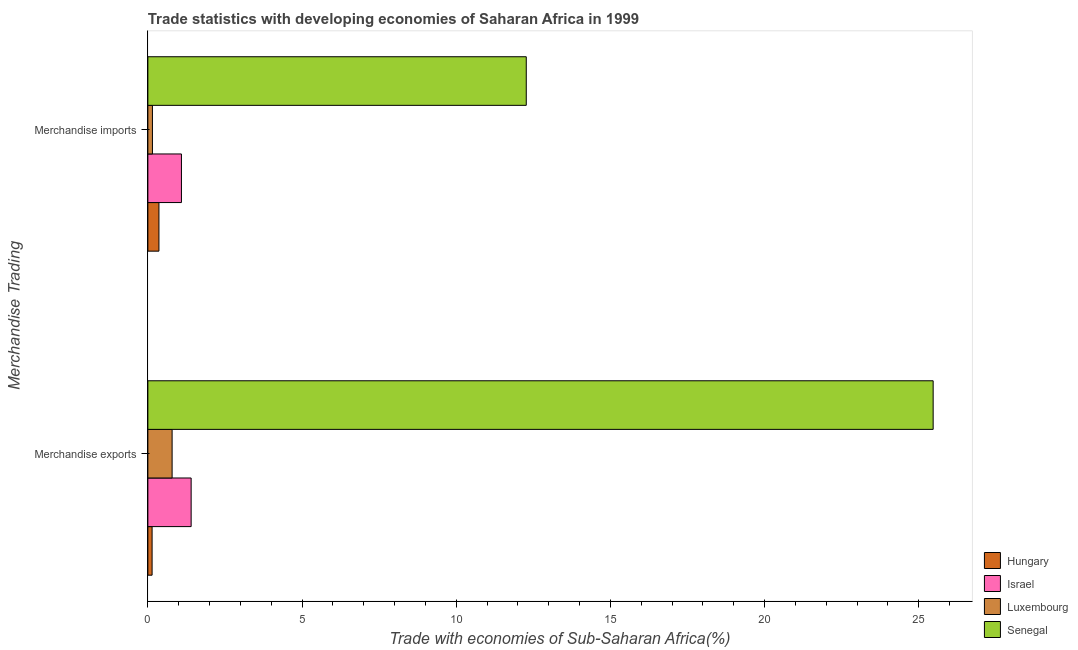How many different coloured bars are there?
Your response must be concise. 4. How many groups of bars are there?
Make the answer very short. 2. Are the number of bars per tick equal to the number of legend labels?
Give a very brief answer. Yes. Are the number of bars on each tick of the Y-axis equal?
Make the answer very short. Yes. How many bars are there on the 1st tick from the bottom?
Give a very brief answer. 4. What is the merchandise exports in Israel?
Give a very brief answer. 1.4. Across all countries, what is the maximum merchandise exports?
Provide a short and direct response. 25.47. Across all countries, what is the minimum merchandise imports?
Keep it short and to the point. 0.15. In which country was the merchandise imports maximum?
Make the answer very short. Senegal. In which country was the merchandise imports minimum?
Offer a terse response. Luxembourg. What is the total merchandise exports in the graph?
Offer a terse response. 27.8. What is the difference between the merchandise imports in Hungary and that in Israel?
Keep it short and to the point. -0.73. What is the difference between the merchandise imports in Israel and the merchandise exports in Luxembourg?
Provide a succinct answer. 0.3. What is the average merchandise exports per country?
Provide a succinct answer. 6.95. What is the difference between the merchandise imports and merchandise exports in Luxembourg?
Make the answer very short. -0.64. What is the ratio of the merchandise imports in Luxembourg to that in Israel?
Your response must be concise. 0.14. Is the merchandise imports in Senegal less than that in Hungary?
Give a very brief answer. No. In how many countries, is the merchandise exports greater than the average merchandise exports taken over all countries?
Offer a very short reply. 1. What does the 2nd bar from the top in Merchandise exports represents?
Provide a short and direct response. Luxembourg. Are all the bars in the graph horizontal?
Your answer should be very brief. Yes. Are the values on the major ticks of X-axis written in scientific E-notation?
Keep it short and to the point. No. Where does the legend appear in the graph?
Offer a terse response. Bottom right. How many legend labels are there?
Offer a terse response. 4. What is the title of the graph?
Ensure brevity in your answer.  Trade statistics with developing economies of Saharan Africa in 1999. Does "Netherlands" appear as one of the legend labels in the graph?
Your answer should be compact. No. What is the label or title of the X-axis?
Offer a terse response. Trade with economies of Sub-Saharan Africa(%). What is the label or title of the Y-axis?
Give a very brief answer. Merchandise Trading. What is the Trade with economies of Sub-Saharan Africa(%) of Hungary in Merchandise exports?
Give a very brief answer. 0.14. What is the Trade with economies of Sub-Saharan Africa(%) of Israel in Merchandise exports?
Keep it short and to the point. 1.4. What is the Trade with economies of Sub-Saharan Africa(%) in Luxembourg in Merchandise exports?
Your answer should be very brief. 0.79. What is the Trade with economies of Sub-Saharan Africa(%) in Senegal in Merchandise exports?
Your response must be concise. 25.47. What is the Trade with economies of Sub-Saharan Africa(%) in Hungary in Merchandise imports?
Offer a very short reply. 0.36. What is the Trade with economies of Sub-Saharan Africa(%) of Israel in Merchandise imports?
Give a very brief answer. 1.09. What is the Trade with economies of Sub-Saharan Africa(%) of Luxembourg in Merchandise imports?
Ensure brevity in your answer.  0.15. What is the Trade with economies of Sub-Saharan Africa(%) in Senegal in Merchandise imports?
Give a very brief answer. 12.27. Across all Merchandise Trading, what is the maximum Trade with economies of Sub-Saharan Africa(%) of Hungary?
Your response must be concise. 0.36. Across all Merchandise Trading, what is the maximum Trade with economies of Sub-Saharan Africa(%) of Israel?
Offer a terse response. 1.4. Across all Merchandise Trading, what is the maximum Trade with economies of Sub-Saharan Africa(%) in Luxembourg?
Keep it short and to the point. 0.79. Across all Merchandise Trading, what is the maximum Trade with economies of Sub-Saharan Africa(%) of Senegal?
Your answer should be very brief. 25.47. Across all Merchandise Trading, what is the minimum Trade with economies of Sub-Saharan Africa(%) in Hungary?
Your response must be concise. 0.14. Across all Merchandise Trading, what is the minimum Trade with economies of Sub-Saharan Africa(%) in Israel?
Offer a very short reply. 1.09. Across all Merchandise Trading, what is the minimum Trade with economies of Sub-Saharan Africa(%) in Luxembourg?
Provide a succinct answer. 0.15. Across all Merchandise Trading, what is the minimum Trade with economies of Sub-Saharan Africa(%) in Senegal?
Your response must be concise. 12.27. What is the total Trade with economies of Sub-Saharan Africa(%) of Hungary in the graph?
Your answer should be compact. 0.5. What is the total Trade with economies of Sub-Saharan Africa(%) of Israel in the graph?
Provide a short and direct response. 2.49. What is the total Trade with economies of Sub-Saharan Africa(%) of Luxembourg in the graph?
Make the answer very short. 0.93. What is the total Trade with economies of Sub-Saharan Africa(%) of Senegal in the graph?
Your answer should be very brief. 37.74. What is the difference between the Trade with economies of Sub-Saharan Africa(%) of Hungary in Merchandise exports and that in Merchandise imports?
Your answer should be compact. -0.22. What is the difference between the Trade with economies of Sub-Saharan Africa(%) in Israel in Merchandise exports and that in Merchandise imports?
Make the answer very short. 0.31. What is the difference between the Trade with economies of Sub-Saharan Africa(%) in Luxembourg in Merchandise exports and that in Merchandise imports?
Your answer should be compact. 0.64. What is the difference between the Trade with economies of Sub-Saharan Africa(%) of Senegal in Merchandise exports and that in Merchandise imports?
Offer a very short reply. 13.2. What is the difference between the Trade with economies of Sub-Saharan Africa(%) of Hungary in Merchandise exports and the Trade with economies of Sub-Saharan Africa(%) of Israel in Merchandise imports?
Keep it short and to the point. -0.95. What is the difference between the Trade with economies of Sub-Saharan Africa(%) of Hungary in Merchandise exports and the Trade with economies of Sub-Saharan Africa(%) of Luxembourg in Merchandise imports?
Ensure brevity in your answer.  -0.01. What is the difference between the Trade with economies of Sub-Saharan Africa(%) of Hungary in Merchandise exports and the Trade with economies of Sub-Saharan Africa(%) of Senegal in Merchandise imports?
Offer a terse response. -12.14. What is the difference between the Trade with economies of Sub-Saharan Africa(%) of Israel in Merchandise exports and the Trade with economies of Sub-Saharan Africa(%) of Luxembourg in Merchandise imports?
Keep it short and to the point. 1.26. What is the difference between the Trade with economies of Sub-Saharan Africa(%) of Israel in Merchandise exports and the Trade with economies of Sub-Saharan Africa(%) of Senegal in Merchandise imports?
Your answer should be very brief. -10.87. What is the difference between the Trade with economies of Sub-Saharan Africa(%) of Luxembourg in Merchandise exports and the Trade with economies of Sub-Saharan Africa(%) of Senegal in Merchandise imports?
Give a very brief answer. -11.49. What is the average Trade with economies of Sub-Saharan Africa(%) in Hungary per Merchandise Trading?
Offer a very short reply. 0.25. What is the average Trade with economies of Sub-Saharan Africa(%) in Israel per Merchandise Trading?
Your answer should be very brief. 1.25. What is the average Trade with economies of Sub-Saharan Africa(%) of Luxembourg per Merchandise Trading?
Your answer should be very brief. 0.47. What is the average Trade with economies of Sub-Saharan Africa(%) in Senegal per Merchandise Trading?
Make the answer very short. 18.87. What is the difference between the Trade with economies of Sub-Saharan Africa(%) in Hungary and Trade with economies of Sub-Saharan Africa(%) in Israel in Merchandise exports?
Ensure brevity in your answer.  -1.27. What is the difference between the Trade with economies of Sub-Saharan Africa(%) of Hungary and Trade with economies of Sub-Saharan Africa(%) of Luxembourg in Merchandise exports?
Provide a succinct answer. -0.65. What is the difference between the Trade with economies of Sub-Saharan Africa(%) of Hungary and Trade with economies of Sub-Saharan Africa(%) of Senegal in Merchandise exports?
Offer a terse response. -25.33. What is the difference between the Trade with economies of Sub-Saharan Africa(%) of Israel and Trade with economies of Sub-Saharan Africa(%) of Luxembourg in Merchandise exports?
Offer a very short reply. 0.62. What is the difference between the Trade with economies of Sub-Saharan Africa(%) in Israel and Trade with economies of Sub-Saharan Africa(%) in Senegal in Merchandise exports?
Provide a short and direct response. -24.07. What is the difference between the Trade with economies of Sub-Saharan Africa(%) in Luxembourg and Trade with economies of Sub-Saharan Africa(%) in Senegal in Merchandise exports?
Make the answer very short. -24.68. What is the difference between the Trade with economies of Sub-Saharan Africa(%) in Hungary and Trade with economies of Sub-Saharan Africa(%) in Israel in Merchandise imports?
Your answer should be very brief. -0.73. What is the difference between the Trade with economies of Sub-Saharan Africa(%) in Hungary and Trade with economies of Sub-Saharan Africa(%) in Luxembourg in Merchandise imports?
Your response must be concise. 0.21. What is the difference between the Trade with economies of Sub-Saharan Africa(%) in Hungary and Trade with economies of Sub-Saharan Africa(%) in Senegal in Merchandise imports?
Provide a succinct answer. -11.91. What is the difference between the Trade with economies of Sub-Saharan Africa(%) in Israel and Trade with economies of Sub-Saharan Africa(%) in Luxembourg in Merchandise imports?
Your answer should be very brief. 0.94. What is the difference between the Trade with economies of Sub-Saharan Africa(%) in Israel and Trade with economies of Sub-Saharan Africa(%) in Senegal in Merchandise imports?
Your answer should be compact. -11.18. What is the difference between the Trade with economies of Sub-Saharan Africa(%) in Luxembourg and Trade with economies of Sub-Saharan Africa(%) in Senegal in Merchandise imports?
Your response must be concise. -12.12. What is the ratio of the Trade with economies of Sub-Saharan Africa(%) of Hungary in Merchandise exports to that in Merchandise imports?
Your answer should be compact. 0.38. What is the ratio of the Trade with economies of Sub-Saharan Africa(%) in Israel in Merchandise exports to that in Merchandise imports?
Provide a succinct answer. 1.29. What is the ratio of the Trade with economies of Sub-Saharan Africa(%) of Luxembourg in Merchandise exports to that in Merchandise imports?
Your answer should be very brief. 5.31. What is the ratio of the Trade with economies of Sub-Saharan Africa(%) of Senegal in Merchandise exports to that in Merchandise imports?
Make the answer very short. 2.08. What is the difference between the highest and the second highest Trade with economies of Sub-Saharan Africa(%) in Hungary?
Offer a very short reply. 0.22. What is the difference between the highest and the second highest Trade with economies of Sub-Saharan Africa(%) in Israel?
Give a very brief answer. 0.31. What is the difference between the highest and the second highest Trade with economies of Sub-Saharan Africa(%) in Luxembourg?
Your answer should be very brief. 0.64. What is the difference between the highest and the second highest Trade with economies of Sub-Saharan Africa(%) of Senegal?
Provide a succinct answer. 13.2. What is the difference between the highest and the lowest Trade with economies of Sub-Saharan Africa(%) in Hungary?
Your answer should be compact. 0.22. What is the difference between the highest and the lowest Trade with economies of Sub-Saharan Africa(%) in Israel?
Keep it short and to the point. 0.31. What is the difference between the highest and the lowest Trade with economies of Sub-Saharan Africa(%) of Luxembourg?
Your answer should be very brief. 0.64. What is the difference between the highest and the lowest Trade with economies of Sub-Saharan Africa(%) of Senegal?
Give a very brief answer. 13.2. 